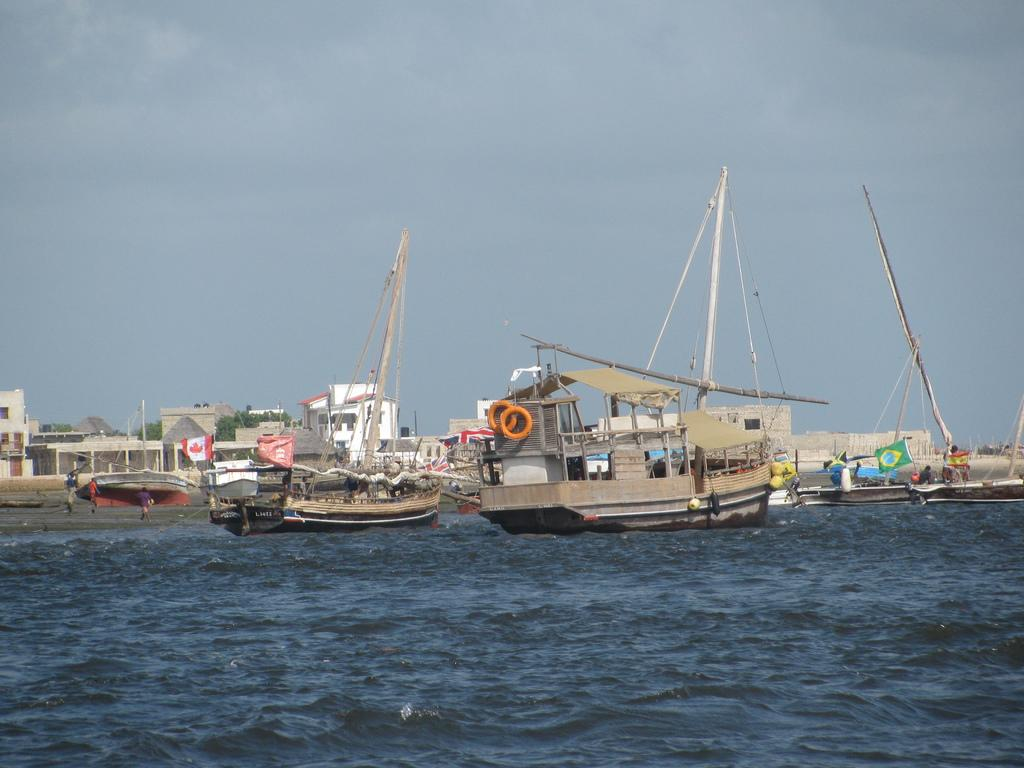What is on the surface of the river in the image? There are boats on the surface of the river in the image. What can be seen in the background of the image? There are buildings and trees in the background of the image. Are there any people visible in the image? Yes, there are people visible in the image. How would you describe the sky in the image? The sky is cloudy in the image. What type of sign can be seen on the tail of the boat in the image? There is no sign or tail present on the boats in the image. What month is it in the image? The month cannot be determined from the image, as there is no information about the date or time of year. 